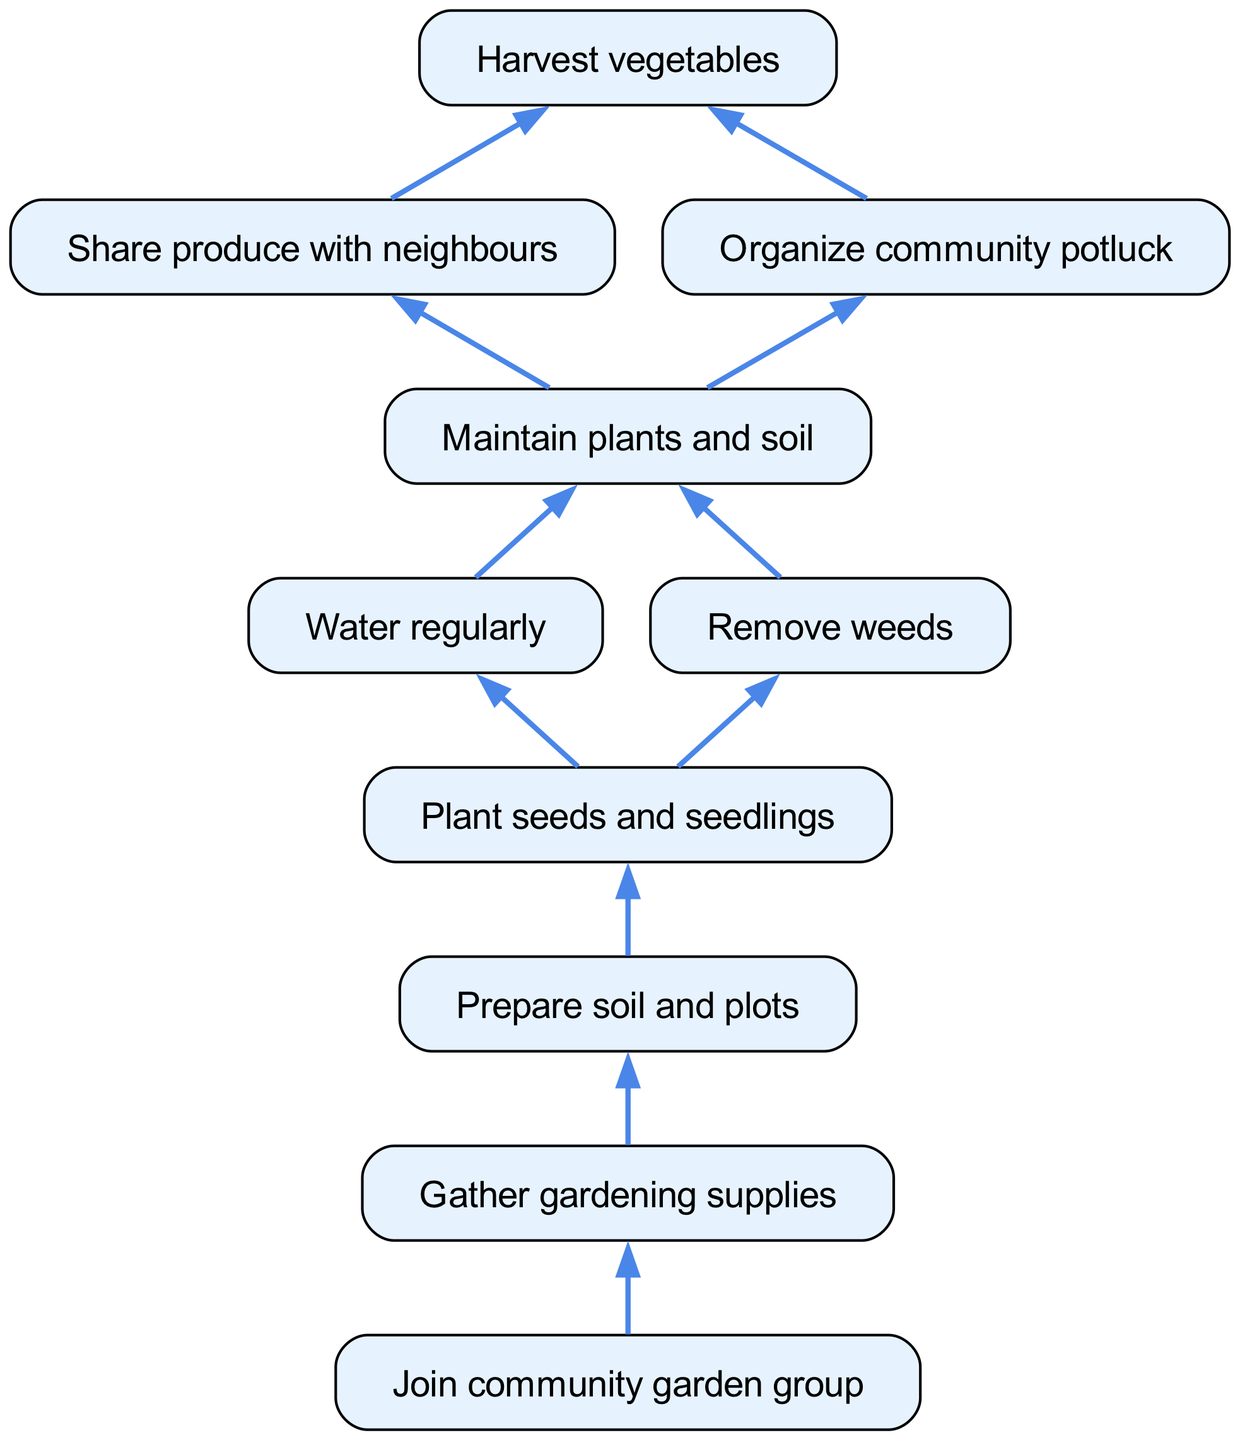What is the final step in the community garden lifecycle? The diagram shows that the process culminates at "Harvest vegetables," which is at the top of the flow. This is the final step before sharing produce or organizing events.
Answer: Harvest vegetables How many connections does "Maintain plants and soil" have? According to the diagram, "Maintain plants and soil" connects to two other steps: "Water regularly" and "Remove weeds." Therefore, it has two connections.
Answer: 2 What activity follows the preparation of soil and plots? By analyzing the flow, after "Prepare soil and plots," the next activity is "Plant seeds and seedlings." This shows a direct progression from preparing to planting.
Answer: Plant seeds and seedlings Which step comes directly after "Remove weeds"? Following "Remove weeds," the next step in the flowchart is "Plant seeds and seedlings." This indicates that removing weeds is part of the maintenance that leads to seeding.
Answer: Plant seeds and seedlings What is the first step to start a community garden? The lifecycle indicates that "Join community garden group" is the first step, which enables all subsequent actions. This is foundational to the whole project.
Answer: Join community garden group What do members do with the vegetables after harvest? Once vegetables are harvested, the next steps include "Share produce with neighbours" and "Organize community potluck," indicating that sharing comes directly after harvest.
Answer: Share produce with neighbours How many total steps are involved in the community garden project? The diagram indicates a total of ten distinct steps, from joining the group to harvesting vegetables. Each node represents a step in the project lifecycle.
Answer: 10 Which step links gathering gardening supplies to starting the planting process? The diagram shows that "Gather gardening supplies" is followed directly by "Prepare soil and plots," linking preparation with the necessary supplies beforehand.
Answer: Prepare soil and plots 